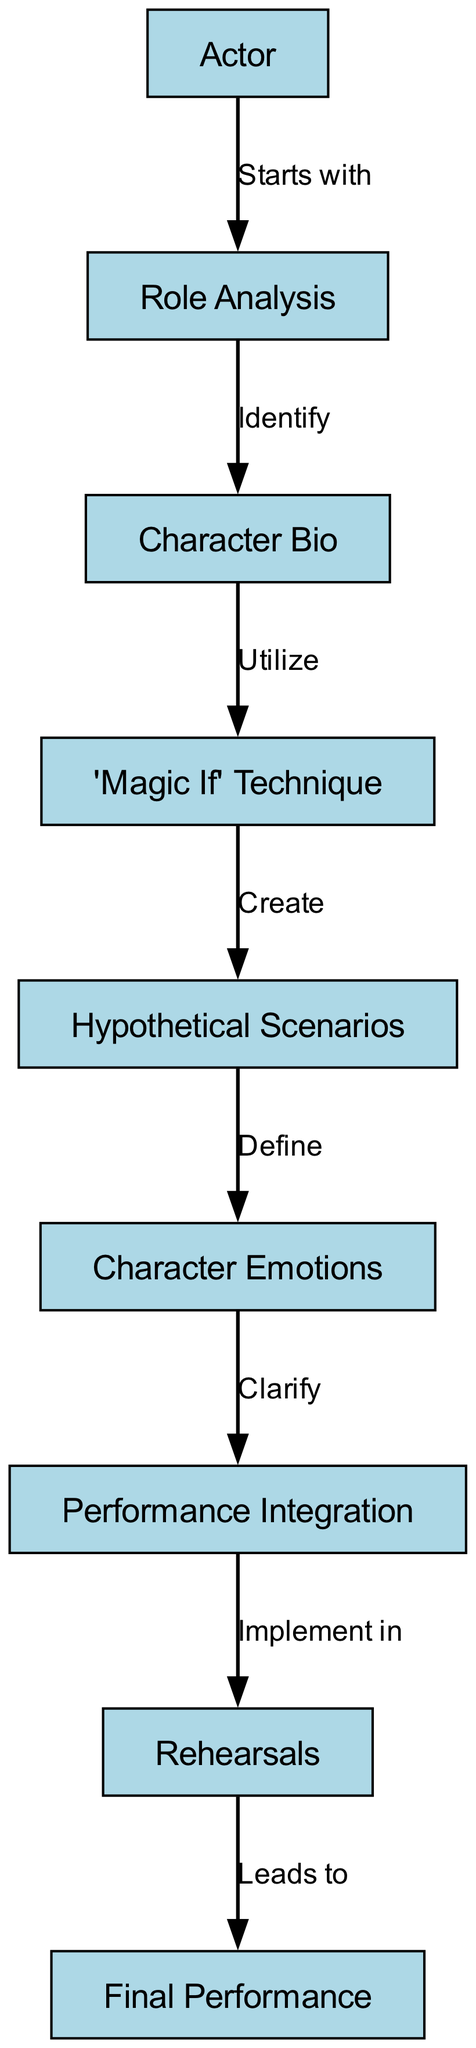What is the first node in the flowchart? The flowchart starts with the "Actor" node, which is the initial step in the process.
Answer: Actor How many nodes are present in the diagram? The diagram has a total of 8 nodes that represent different stages in the process of utilizing the "Magic If" technique.
Answer: 8 What relationship does "Role Analysis" have with "Character Bio"? "Role Analysis" identifies "Character Bio" as the next step in the flowchart, indicating a clear relationship between these two stages.
Answer: Identify Which node follows the "Magic If" node? The "Magic If" node creates "Hypothetical Scenarios," which is the next step in the flowchart.
Answer: Hypothetical Scenarios What do "Character Emotions" clarify in the flow? "Character Emotions" clarify the "Performance Integration," which connects the emotions to the performance aspect.
Answer: Performance Integration What does "Rehearsals" lead to? The "Rehearsals" node leads to the "Final Performance," indicating that rehearsing culminates in the actual performance.
Answer: Final Performance Name the process that begins with the "Actor." The process that begins with the "Actor" is the comprehensive preparation to employ the "Magic If" technique.
Answer: Role Analysis What is the relationship between "Hypothetical Scenarios" and "Character Emotions"? "Hypothetical Scenarios" defines "Character Emotions," illustrating how imagining situations informs the emotional aspects of the character.
Answer: Define 